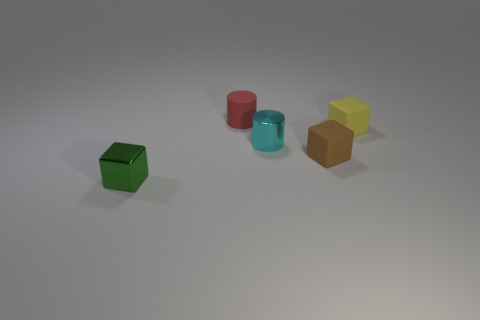What is the color of the other small thing that is the same shape as the tiny cyan object?
Ensure brevity in your answer.  Red. What number of yellow things have the same material as the brown cube?
Your answer should be compact. 1. What material is the cylinder that is in front of the object on the right side of the rubber cube that is in front of the yellow rubber block?
Your answer should be compact. Metal. What is the color of the tiny metal thing on the left side of the small metal thing that is behind the green block?
Offer a very short reply. Green. There is a rubber cylinder that is the same size as the yellow object; what color is it?
Offer a very short reply. Red. What number of small things are yellow blocks or green blocks?
Provide a short and direct response. 2. Is the number of metallic objects that are on the right side of the matte cylinder greater than the number of cyan metallic cylinders that are in front of the green metal thing?
Ensure brevity in your answer.  Yes. How many other things are there of the same size as the green block?
Provide a short and direct response. 4. Do the small block that is to the left of the red cylinder and the tiny cyan object have the same material?
Offer a terse response. Yes. What number of other objects are there of the same shape as the red matte thing?
Provide a short and direct response. 1. 